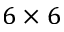Convert formula to latex. <formula><loc_0><loc_0><loc_500><loc_500>6 \times 6</formula> 